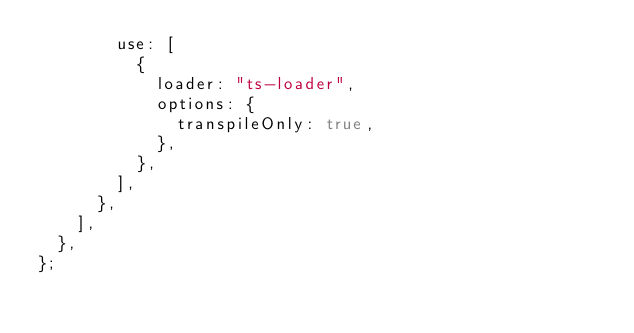<code> <loc_0><loc_0><loc_500><loc_500><_JavaScript_>        use: [
          {
            loader: "ts-loader",
            options: {
              transpileOnly: true,
            },
          },
        ],
      },
    ],
  },
};
</code> 